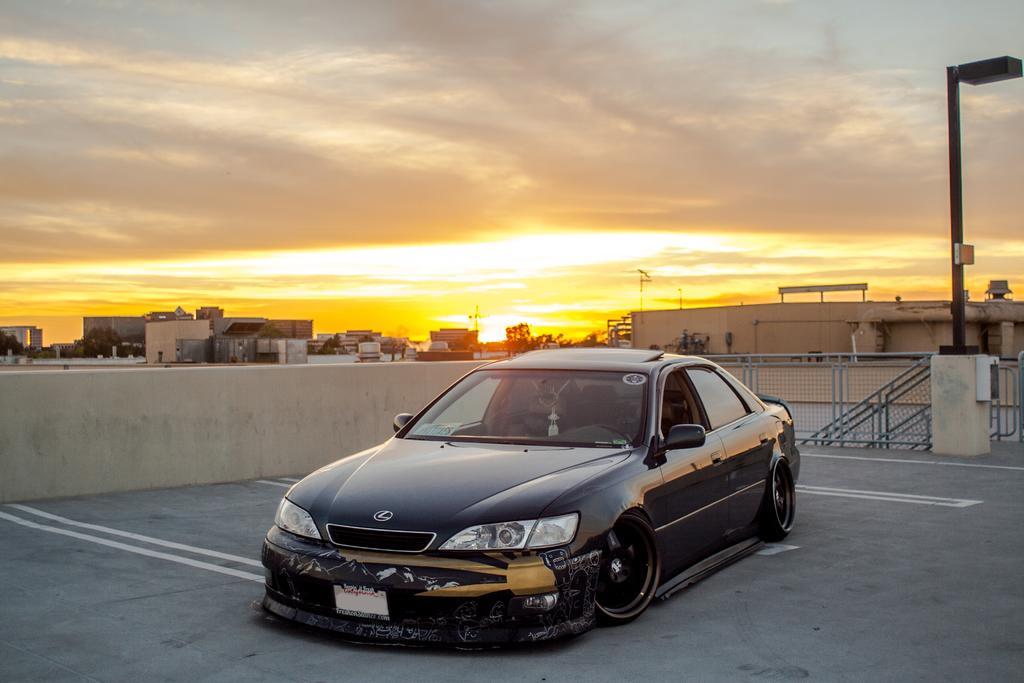Can you describe this image briefly? In the background we can see the sky. In this picture we can see buildings, trees, poles, railings and few objects. This picture is mainly highlighted with a black car. 